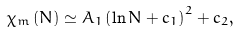<formula> <loc_0><loc_0><loc_500><loc_500>\chi _ { m } \left ( N \right ) \simeq A _ { 1 } \left ( \ln N + c _ { 1 } \right ) ^ { 2 } + c _ { 2 } ,</formula> 